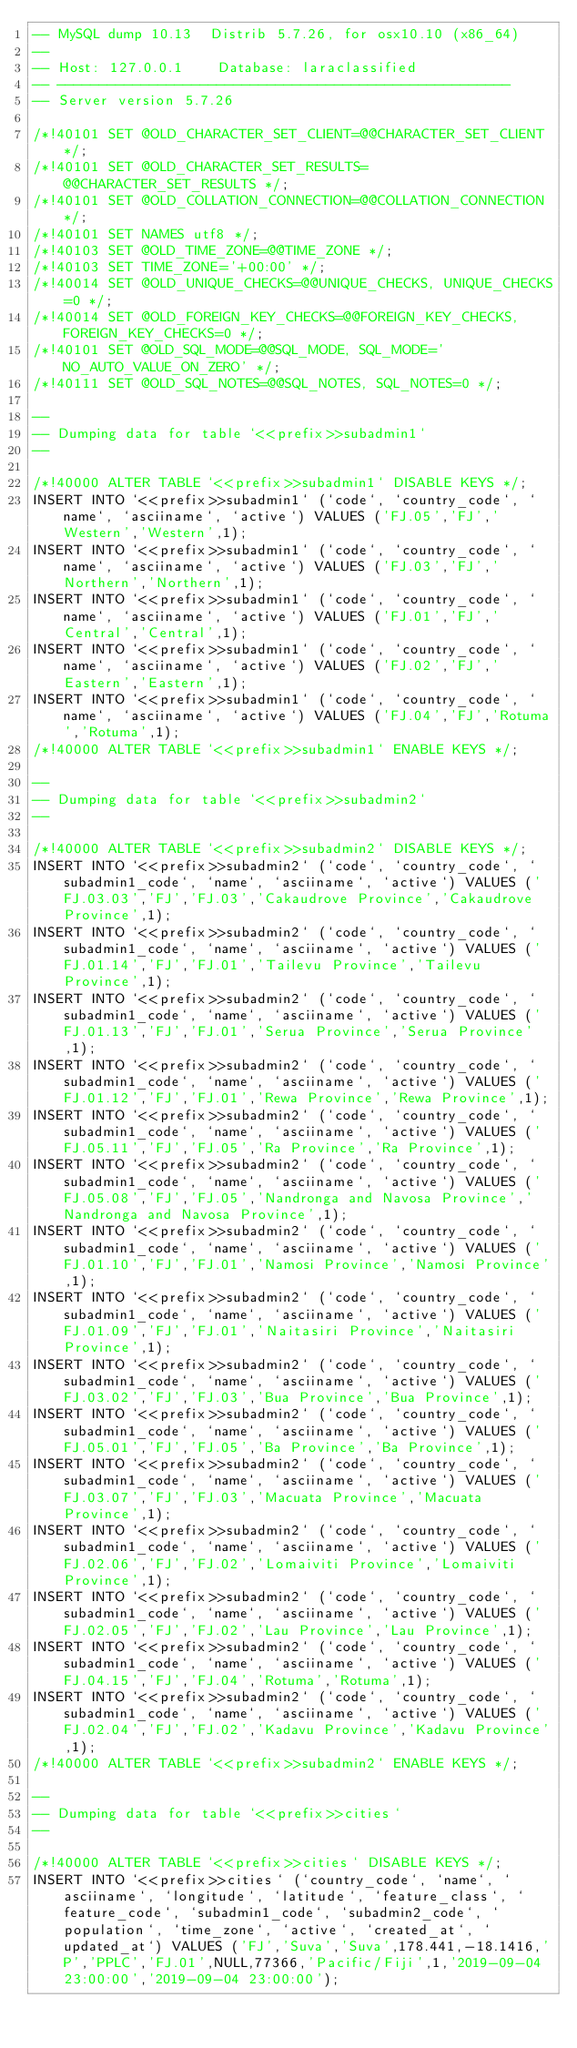<code> <loc_0><loc_0><loc_500><loc_500><_SQL_>-- MySQL dump 10.13  Distrib 5.7.26, for osx10.10 (x86_64)
--
-- Host: 127.0.0.1    Database: laraclassified
-- ------------------------------------------------------
-- Server version	5.7.26

/*!40101 SET @OLD_CHARACTER_SET_CLIENT=@@CHARACTER_SET_CLIENT */;
/*!40101 SET @OLD_CHARACTER_SET_RESULTS=@@CHARACTER_SET_RESULTS */;
/*!40101 SET @OLD_COLLATION_CONNECTION=@@COLLATION_CONNECTION */;
/*!40101 SET NAMES utf8 */;
/*!40103 SET @OLD_TIME_ZONE=@@TIME_ZONE */;
/*!40103 SET TIME_ZONE='+00:00' */;
/*!40014 SET @OLD_UNIQUE_CHECKS=@@UNIQUE_CHECKS, UNIQUE_CHECKS=0 */;
/*!40014 SET @OLD_FOREIGN_KEY_CHECKS=@@FOREIGN_KEY_CHECKS, FOREIGN_KEY_CHECKS=0 */;
/*!40101 SET @OLD_SQL_MODE=@@SQL_MODE, SQL_MODE='NO_AUTO_VALUE_ON_ZERO' */;
/*!40111 SET @OLD_SQL_NOTES=@@SQL_NOTES, SQL_NOTES=0 */;

--
-- Dumping data for table `<<prefix>>subadmin1`
--

/*!40000 ALTER TABLE `<<prefix>>subadmin1` DISABLE KEYS */;
INSERT INTO `<<prefix>>subadmin1` (`code`, `country_code`, `name`, `asciiname`, `active`) VALUES ('FJ.05','FJ','Western','Western',1);
INSERT INTO `<<prefix>>subadmin1` (`code`, `country_code`, `name`, `asciiname`, `active`) VALUES ('FJ.03','FJ','Northern','Northern',1);
INSERT INTO `<<prefix>>subadmin1` (`code`, `country_code`, `name`, `asciiname`, `active`) VALUES ('FJ.01','FJ','Central','Central',1);
INSERT INTO `<<prefix>>subadmin1` (`code`, `country_code`, `name`, `asciiname`, `active`) VALUES ('FJ.02','FJ','Eastern','Eastern',1);
INSERT INTO `<<prefix>>subadmin1` (`code`, `country_code`, `name`, `asciiname`, `active`) VALUES ('FJ.04','FJ','Rotuma','Rotuma',1);
/*!40000 ALTER TABLE `<<prefix>>subadmin1` ENABLE KEYS */;

--
-- Dumping data for table `<<prefix>>subadmin2`
--

/*!40000 ALTER TABLE `<<prefix>>subadmin2` DISABLE KEYS */;
INSERT INTO `<<prefix>>subadmin2` (`code`, `country_code`, `subadmin1_code`, `name`, `asciiname`, `active`) VALUES ('FJ.03.03','FJ','FJ.03','Cakaudrove Province','Cakaudrove Province',1);
INSERT INTO `<<prefix>>subadmin2` (`code`, `country_code`, `subadmin1_code`, `name`, `asciiname`, `active`) VALUES ('FJ.01.14','FJ','FJ.01','Tailevu Province','Tailevu Province',1);
INSERT INTO `<<prefix>>subadmin2` (`code`, `country_code`, `subadmin1_code`, `name`, `asciiname`, `active`) VALUES ('FJ.01.13','FJ','FJ.01','Serua Province','Serua Province',1);
INSERT INTO `<<prefix>>subadmin2` (`code`, `country_code`, `subadmin1_code`, `name`, `asciiname`, `active`) VALUES ('FJ.01.12','FJ','FJ.01','Rewa Province','Rewa Province',1);
INSERT INTO `<<prefix>>subadmin2` (`code`, `country_code`, `subadmin1_code`, `name`, `asciiname`, `active`) VALUES ('FJ.05.11','FJ','FJ.05','Ra Province','Ra Province',1);
INSERT INTO `<<prefix>>subadmin2` (`code`, `country_code`, `subadmin1_code`, `name`, `asciiname`, `active`) VALUES ('FJ.05.08','FJ','FJ.05','Nandronga and Navosa Province','Nandronga and Navosa Province',1);
INSERT INTO `<<prefix>>subadmin2` (`code`, `country_code`, `subadmin1_code`, `name`, `asciiname`, `active`) VALUES ('FJ.01.10','FJ','FJ.01','Namosi Province','Namosi Province',1);
INSERT INTO `<<prefix>>subadmin2` (`code`, `country_code`, `subadmin1_code`, `name`, `asciiname`, `active`) VALUES ('FJ.01.09','FJ','FJ.01','Naitasiri Province','Naitasiri Province',1);
INSERT INTO `<<prefix>>subadmin2` (`code`, `country_code`, `subadmin1_code`, `name`, `asciiname`, `active`) VALUES ('FJ.03.02','FJ','FJ.03','Bua Province','Bua Province',1);
INSERT INTO `<<prefix>>subadmin2` (`code`, `country_code`, `subadmin1_code`, `name`, `asciiname`, `active`) VALUES ('FJ.05.01','FJ','FJ.05','Ba Province','Ba Province',1);
INSERT INTO `<<prefix>>subadmin2` (`code`, `country_code`, `subadmin1_code`, `name`, `asciiname`, `active`) VALUES ('FJ.03.07','FJ','FJ.03','Macuata Province','Macuata Province',1);
INSERT INTO `<<prefix>>subadmin2` (`code`, `country_code`, `subadmin1_code`, `name`, `asciiname`, `active`) VALUES ('FJ.02.06','FJ','FJ.02','Lomaiviti Province','Lomaiviti Province',1);
INSERT INTO `<<prefix>>subadmin2` (`code`, `country_code`, `subadmin1_code`, `name`, `asciiname`, `active`) VALUES ('FJ.02.05','FJ','FJ.02','Lau Province','Lau Province',1);
INSERT INTO `<<prefix>>subadmin2` (`code`, `country_code`, `subadmin1_code`, `name`, `asciiname`, `active`) VALUES ('FJ.04.15','FJ','FJ.04','Rotuma','Rotuma',1);
INSERT INTO `<<prefix>>subadmin2` (`code`, `country_code`, `subadmin1_code`, `name`, `asciiname`, `active`) VALUES ('FJ.02.04','FJ','FJ.02','Kadavu Province','Kadavu Province',1);
/*!40000 ALTER TABLE `<<prefix>>subadmin2` ENABLE KEYS */;

--
-- Dumping data for table `<<prefix>>cities`
--

/*!40000 ALTER TABLE `<<prefix>>cities` DISABLE KEYS */;
INSERT INTO `<<prefix>>cities` (`country_code`, `name`, `asciiname`, `longitude`, `latitude`, `feature_class`, `feature_code`, `subadmin1_code`, `subadmin2_code`, `population`, `time_zone`, `active`, `created_at`, `updated_at`) VALUES ('FJ','Suva','Suva',178.441,-18.1416,'P','PPLC','FJ.01',NULL,77366,'Pacific/Fiji',1,'2019-09-04 23:00:00','2019-09-04 23:00:00');</code> 